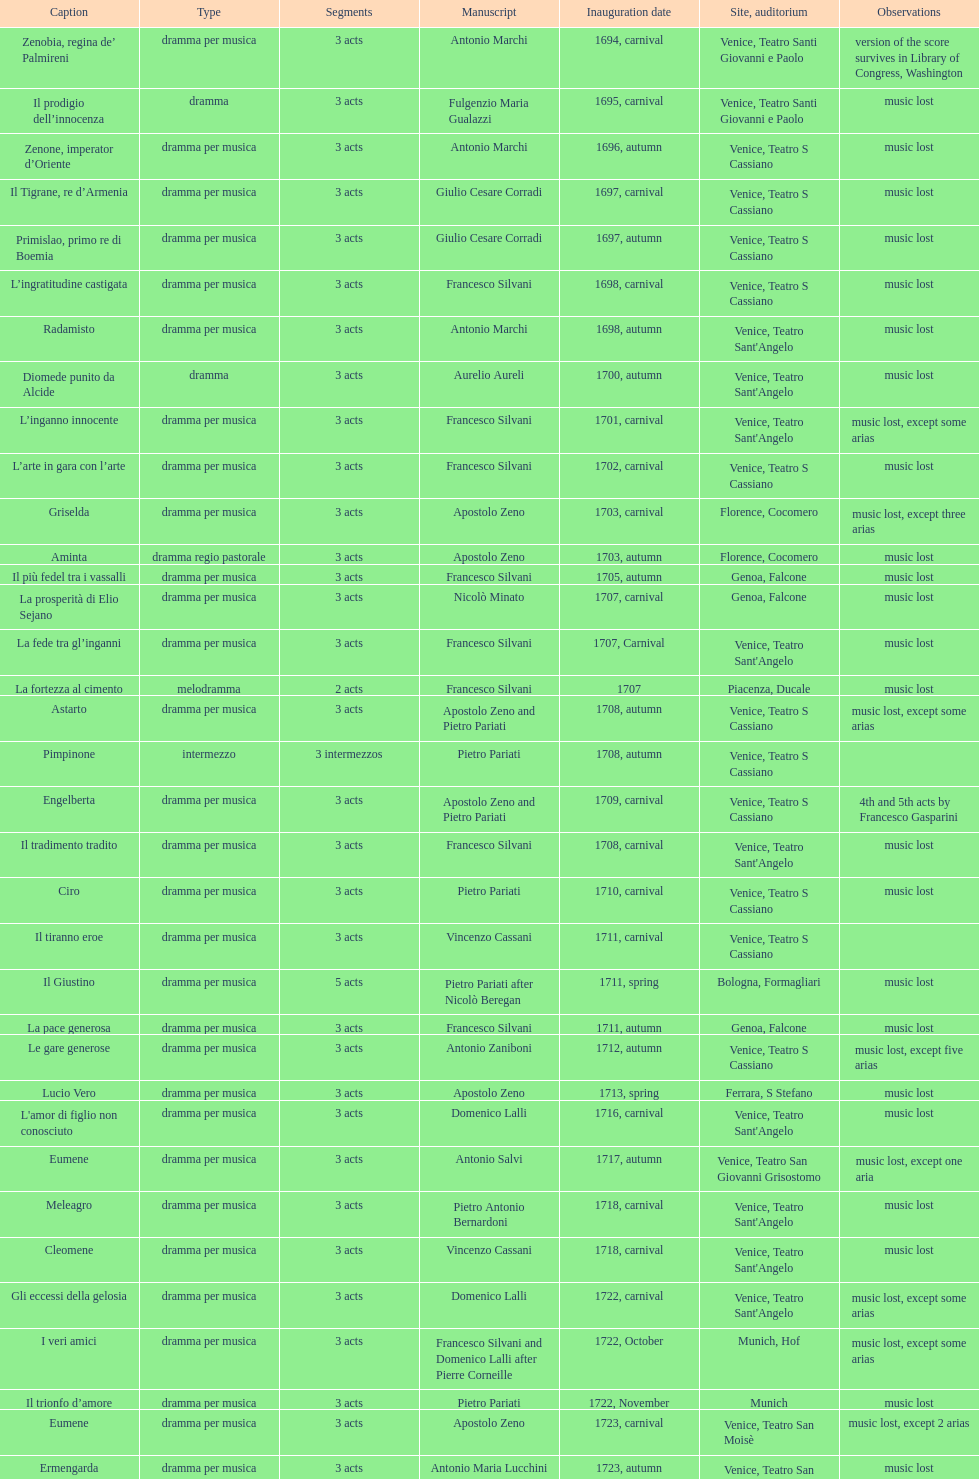What number of acts does il giustino have? 5. 